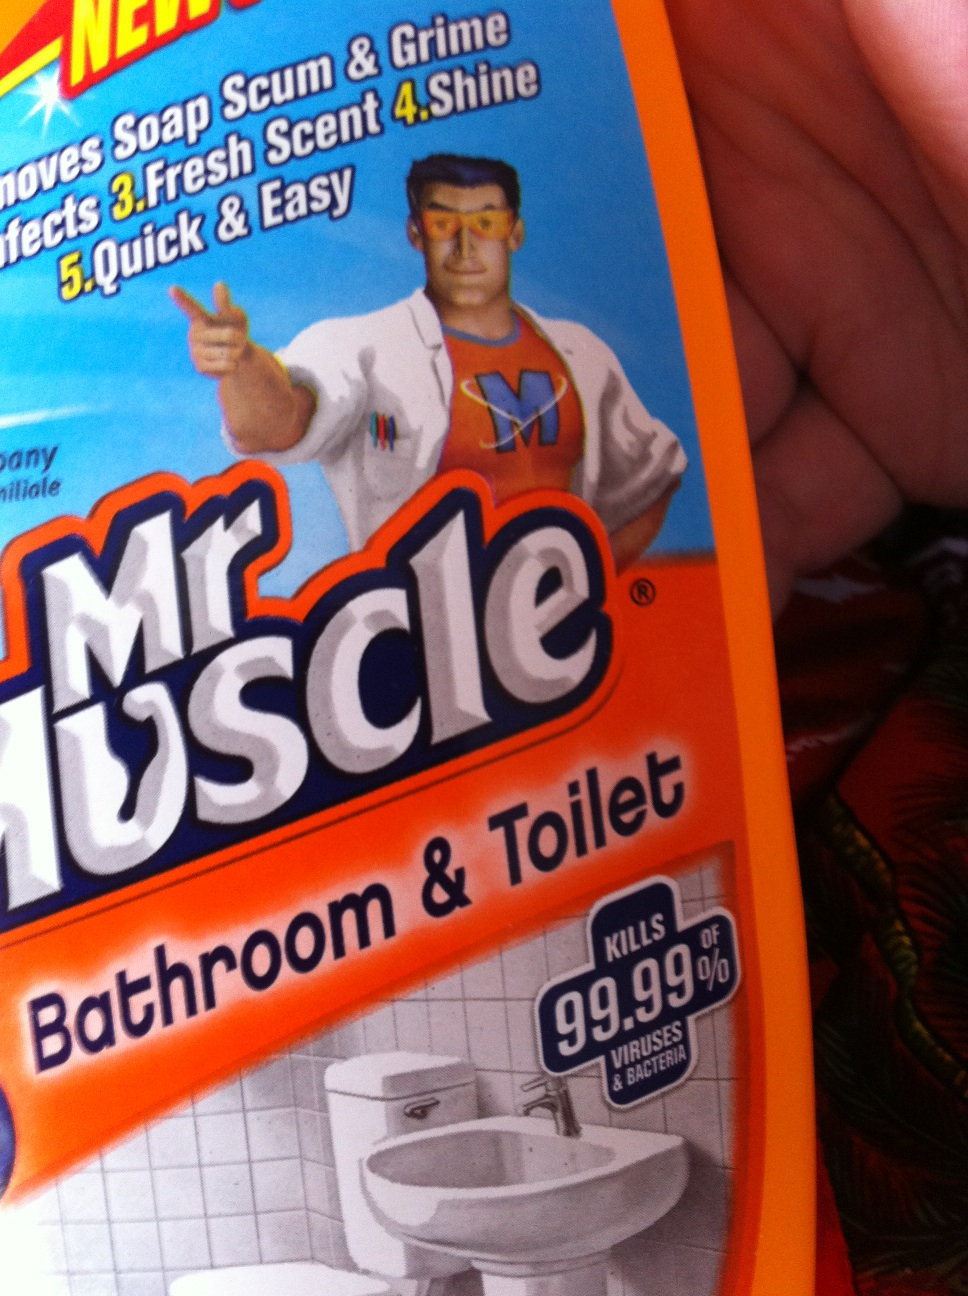Hello. Can someone please tell me what this is please? Many thanks and any instructions for us on the bottle? Thank you. from Vizwiz The image shows a bottle of 'Mr. Muscle Bathroom & Toilet' cleaner. This product is designed to remove soap scum and grime, provides a fresh scent, adds shine, and is claimed to be quick and easy to use. It kills up to 99.99% of viruses and bacteria. For instructions, you typically need to apply it to the surface, leave it for a few minutes, scrub if necessary, and then rinse or wipe clean. Always read the label on the bottle for specific usage directions and safety precautions such as wearing gloves and ensuring good ventilation. 